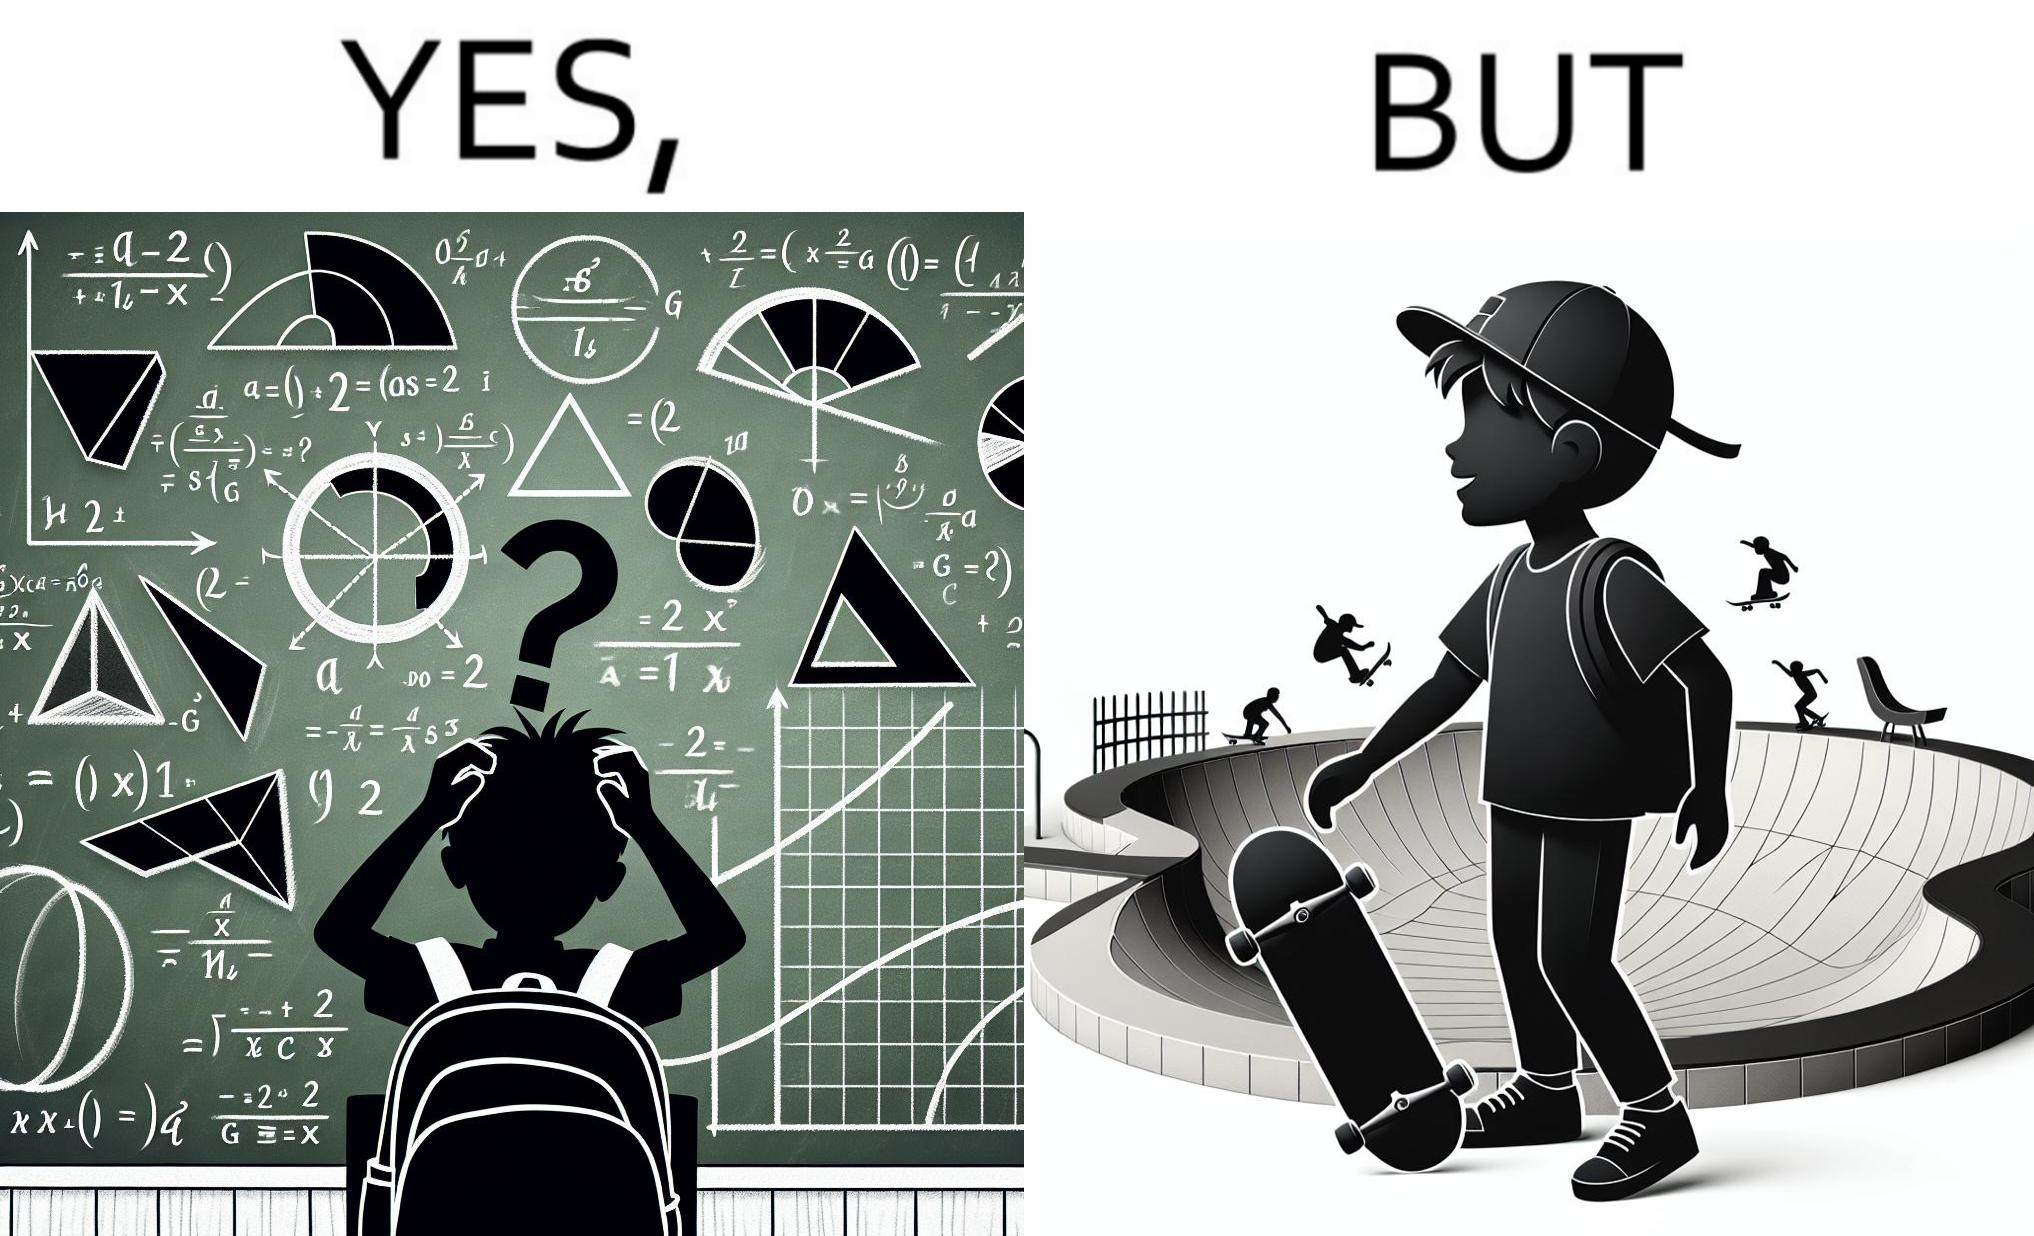Is this a satirical image? Yes, this image is satirical. 